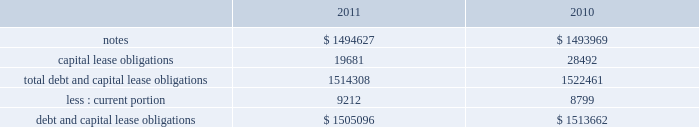Note 17 .
Debt our debt as of december 2 , 2011 and december 3 , 2010 consisted of the following ( in thousands ) : capital lease obligations total debt and capital lease obligations less : current portion debt and capital lease obligations $ 1494627 19681 1514308 $ 1505096 $ 1493969 28492 1522461 $ 1513662 in february 2010 , we issued $ 600.0 million of 3.25% ( 3.25 % ) senior notes due february 1 , 2015 ( the 201c2015 notes 201d ) and $ 900.0 million of 4.75% ( 4.75 % ) senior notes due february 1 , 2020 ( the 201c2020 notes 201d and , together with the 2015 notes , the 201cnotes 201d ) .
Our proceeds were approximately $ 1.5 billion and were net of an issuance discount of $ 6.6 million .
The notes rank equally with our other unsecured and unsubordinated indebtedness .
In addition , we incurred issuance costs of approximately $ 10.7 million .
Both the discount and issuance costs are being amortized to interest expense over the respective terms of the notes using the effective interest method .
The effective interest rate including the discount and issuance costs is 3.45% ( 3.45 % ) for the 2015 notes and 4.92% ( 4.92 % ) for the 2020 notes .
Interest is payable semi-annually , in arrears , on february 1 and august 1 , commencing on august 1 , 2010 .
During fiscal 2011 interest payments totaled $ 62.3 million .
The proceeds from the notes are available for general corporate purposes , including repayment of any balance outstanding on our credit facility .
Based on quoted market prices , the fair value of the notes was approximately $ 1.6 billion as of december 2 , 2011 .
We may redeem the notes at any time , subject to a make whole premium .
In addition , upon the occurrence of certain change of control triggering events , we may be required to repurchase the notes , at a price equal to 101% ( 101 % ) of their principal amount , plus accrued and unpaid interest to the date of repurchase .
The notes also include covenants that limit our ability to grant liens on assets and to enter into sale and leaseback transactions , subject to significant allowances .
As of december 2 , 2011 , we were in compliance with all of the covenants .
Credit agreement in august 2007 , we entered into an amendment to our credit agreement dated february 2007 ( the 201camendment 201d ) , which increased the total senior unsecured revolving facility from $ 500.0 million to $ 1.0 billion .
The amendment also permits us to request one-year extensions effective on each anniversary of the closing date of the original agreement , subject to the majority consent of the lenders .
We also retain an option to request an additional $ 500.0 million in commitments , for a maximum aggregate facility of $ 1.5 billion .
In february 2008 , we entered into a second amendment to the credit agreement dated february 26 , 2008 , which extended the maturity date of the facility by one year to february 16 , 2013 .
The facility would terminate at this date if no additional extensions have been requested and granted .
All other terms and conditions remain the same .
The facility contains a financial covenant requiring us not to exceed a certain maximum leverage ratio .
At our option , borrowings under the facility accrue interest based on either the london interbank offered rate ( 201clibor 201d ) for one , two , three or six months , or longer periods with bank consent , plus a margin according to a pricing grid tied to this financial covenant , or a base rate .
The margin is set at rates between 0.20% ( 0.20 % ) and 0.475% ( 0.475 % ) .
Commitment fees are payable on the facility at rates between 0.05% ( 0.05 % ) and 0.15% ( 0.15 % ) per year based on the same pricing grid .
The facility is available to provide loans to us and certain of our subsidiaries for general corporate purposes .
On february 1 , 2010 , we paid the outstanding balance on our credit facility and the entire $ 1.0 billion credit line under this facility remains available for borrowing .
Capital lease obligation in june 2010 , we entered into a sale-leaseback agreement to sell equipment totaling $ 32.2 million and leaseback the same equipment over a period of 43 months .
This transaction was classified as a capital lease obligation and recorded at fair value .
As of december 2 , 2011 , our capital lease obligations of $ 19.7 million includes $ 9.2 million of current debt .
Table of contents adobe systems incorporated notes to consolidated financial statements ( continued ) .
Note 17 .
Debt our debt as of december 2 , 2011 and december 3 , 2010 consisted of the following ( in thousands ) : capital lease obligations total debt and capital lease obligations less : current portion debt and capital lease obligations $ 1494627 19681 1514308 $ 1505096 $ 1493969 28492 1522461 $ 1513662 in february 2010 , we issued $ 600.0 million of 3.25% ( 3.25 % ) senior notes due february 1 , 2015 ( the 201c2015 notes 201d ) and $ 900.0 million of 4.75% ( 4.75 % ) senior notes due february 1 , 2020 ( the 201c2020 notes 201d and , together with the 2015 notes , the 201cnotes 201d ) .
Our proceeds were approximately $ 1.5 billion and were net of an issuance discount of $ 6.6 million .
The notes rank equally with our other unsecured and unsubordinated indebtedness .
In addition , we incurred issuance costs of approximately $ 10.7 million .
Both the discount and issuance costs are being amortized to interest expense over the respective terms of the notes using the effective interest method .
The effective interest rate including the discount and issuance costs is 3.45% ( 3.45 % ) for the 2015 notes and 4.92% ( 4.92 % ) for the 2020 notes .
Interest is payable semi-annually , in arrears , on february 1 and august 1 , commencing on august 1 , 2010 .
During fiscal 2011 interest payments totaled $ 62.3 million .
The proceeds from the notes are available for general corporate purposes , including repayment of any balance outstanding on our credit facility .
Based on quoted market prices , the fair value of the notes was approximately $ 1.6 billion as of december 2 , 2011 .
We may redeem the notes at any time , subject to a make whole premium .
In addition , upon the occurrence of certain change of control triggering events , we may be required to repurchase the notes , at a price equal to 101% ( 101 % ) of their principal amount , plus accrued and unpaid interest to the date of repurchase .
The notes also include covenants that limit our ability to grant liens on assets and to enter into sale and leaseback transactions , subject to significant allowances .
As of december 2 , 2011 , we were in compliance with all of the covenants .
Credit agreement in august 2007 , we entered into an amendment to our credit agreement dated february 2007 ( the 201camendment 201d ) , which increased the total senior unsecured revolving facility from $ 500.0 million to $ 1.0 billion .
The amendment also permits us to request one-year extensions effective on each anniversary of the closing date of the original agreement , subject to the majority consent of the lenders .
We also retain an option to request an additional $ 500.0 million in commitments , for a maximum aggregate facility of $ 1.5 billion .
In february 2008 , we entered into a second amendment to the credit agreement dated february 26 , 2008 , which extended the maturity date of the facility by one year to february 16 , 2013 .
The facility would terminate at this date if no additional extensions have been requested and granted .
All other terms and conditions remain the same .
The facility contains a financial covenant requiring us not to exceed a certain maximum leverage ratio .
At our option , borrowings under the facility accrue interest based on either the london interbank offered rate ( 201clibor 201d ) for one , two , three or six months , or longer periods with bank consent , plus a margin according to a pricing grid tied to this financial covenant , or a base rate .
The margin is set at rates between 0.20% ( 0.20 % ) and 0.475% ( 0.475 % ) .
Commitment fees are payable on the facility at rates between 0.05% ( 0.05 % ) and 0.15% ( 0.15 % ) per year based on the same pricing grid .
The facility is available to provide loans to us and certain of our subsidiaries for general corporate purposes .
On february 1 , 2010 , we paid the outstanding balance on our credit facility and the entire $ 1.0 billion credit line under this facility remains available for borrowing .
Capital lease obligation in june 2010 , we entered into a sale-leaseback agreement to sell equipment totaling $ 32.2 million and leaseback the same equipment over a period of 43 months .
This transaction was classified as a capital lease obligation and recorded at fair value .
As of december 2 , 2011 , our capital lease obligations of $ 19.7 million includes $ 9.2 million of current debt .
Table of contents adobe systems incorporated notes to consolidated financial statements ( continued ) .
What portion of the total debt and capital lease obligations is included in the section of current liabilities in 2011? 
Computations: (9212 / 1514308)
Answer: 0.00608. 